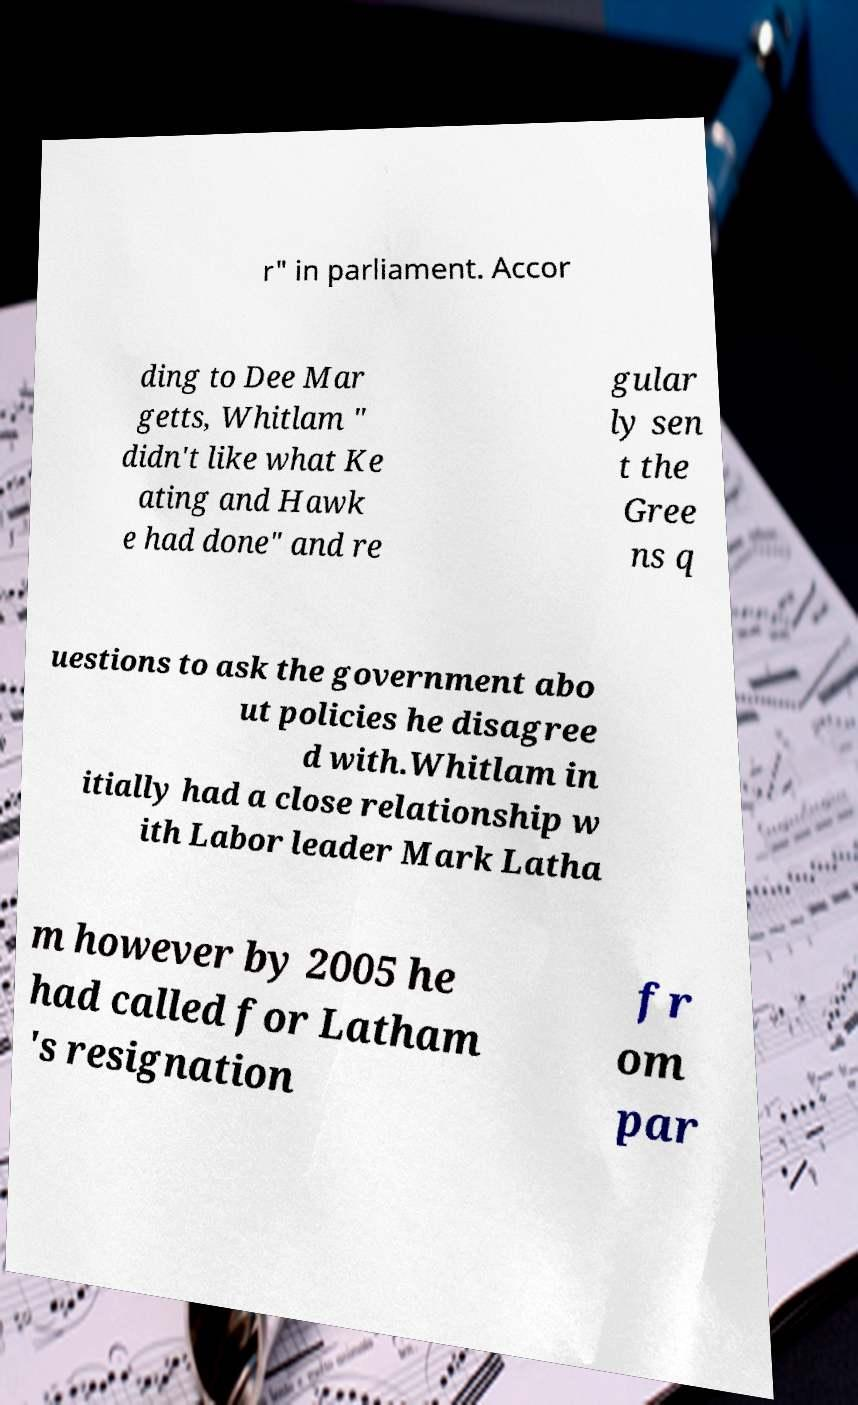Could you assist in decoding the text presented in this image and type it out clearly? r" in parliament. Accor ding to Dee Mar getts, Whitlam " didn't like what Ke ating and Hawk e had done" and re gular ly sen t the Gree ns q uestions to ask the government abo ut policies he disagree d with.Whitlam in itially had a close relationship w ith Labor leader Mark Latha m however by 2005 he had called for Latham 's resignation fr om par 